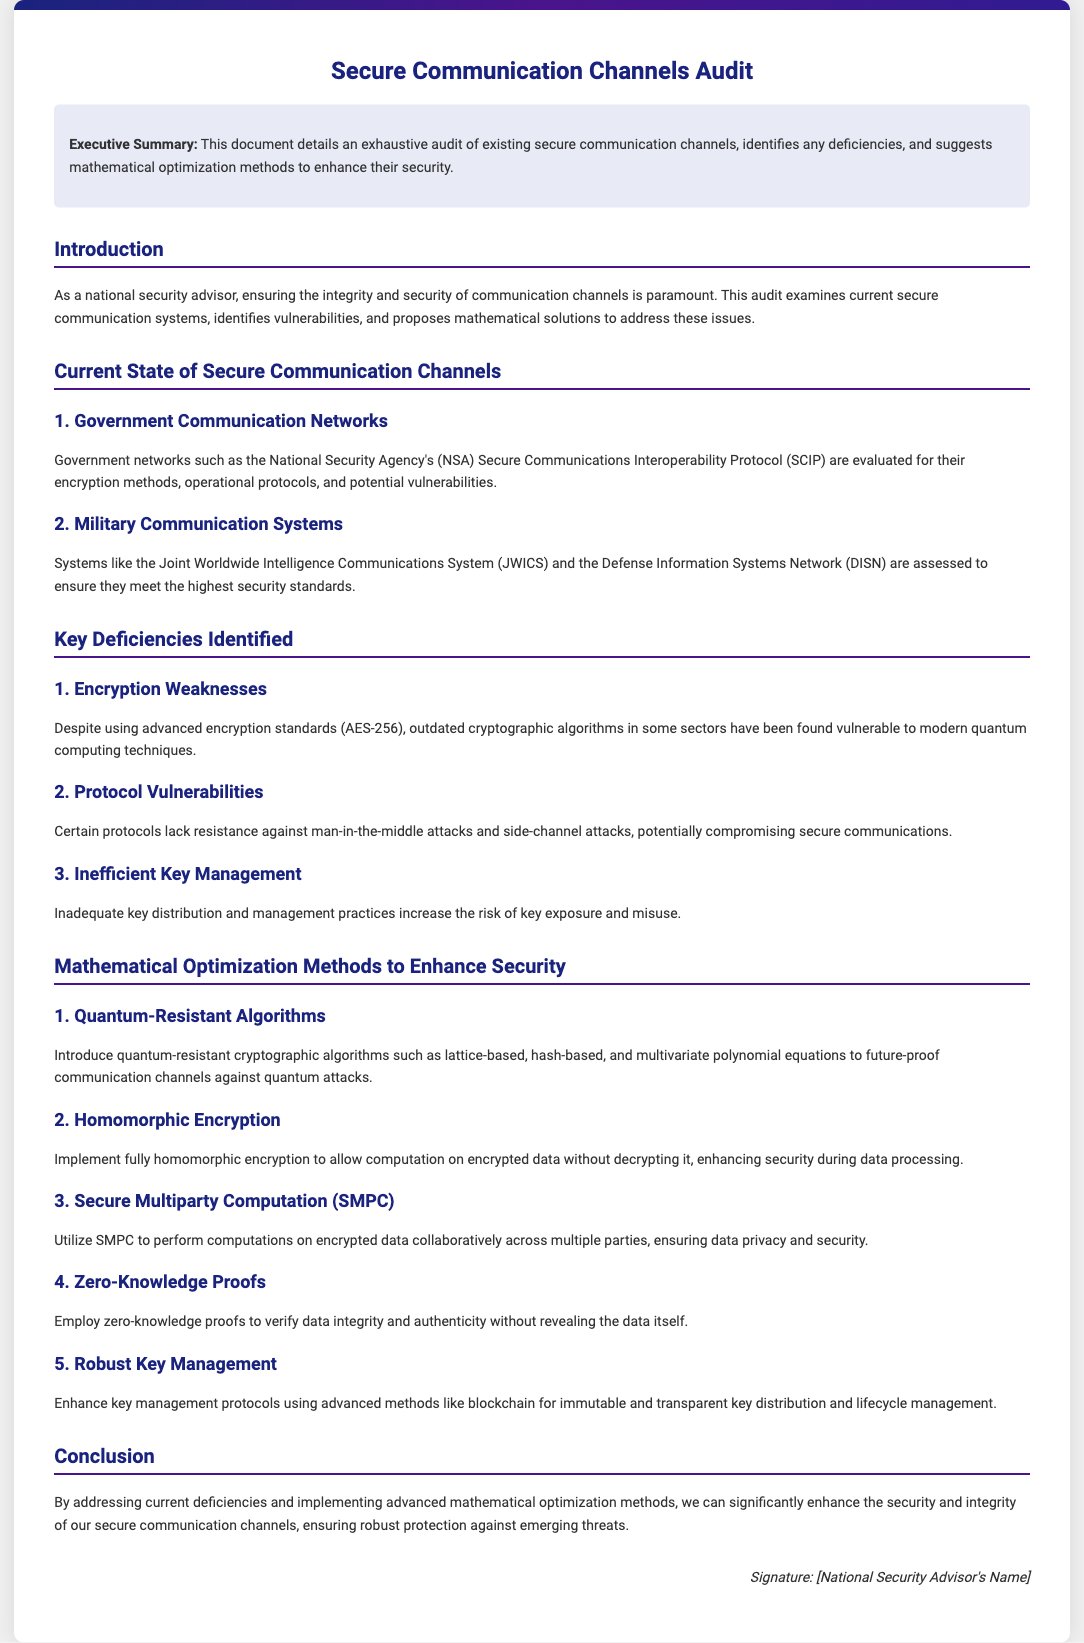What is the title of the document? The title of the document is prominently displayed at the top and indicates the subject of the audit.
Answer: Secure Communication Channels Audit What is highlighted in the executive summary? The executive summary provides a brief overview of the audit's purpose, which is to identify deficiencies and suggest improvements.
Answer: An exhaustive audit of existing secure communication channels, highlights any deficiencies and suggests mathematical optimization methods to enhance their security What encryption standard is mentioned in the document? The document references a specific encryption standard that is evaluated for its security in government communication networks.
Answer: AES-256 What are some identified protocol vulnerabilities? The document outlines specific types of attacks that certain protocols are vulnerable to, emphasizing their security weaknesses.
Answer: Man-in-the-middle attacks and side-channel attacks Name one mathematical optimization method proposed. The document lists multiple methods aimed at enhancing security and identifies at least one specific technique.
Answer: Quantum-resistant algorithms How many key deficiencies are identified in the document? Key deficiencies are enumerated in the section discussing vulnerabilities, providing a clear number to reference.
Answer: Three What does SMPC stand for? The document mentions this term within the context of mathematical methods for secure communication, which stands for a specific type of computation.
Answer: Secure Multiparty Computation What is the conclusion about enhancing security and integrity? The conclusion summarizes the overall goal and outcome expected from addressing the deficiencies identified earlier in the audit.
Answer: Significantly enhance the security and integrity of our secure communication channels Who signs the document? The signature section specifies the individual responsible for the content of the document, indicating their role.
Answer: National Security Advisor's Name 